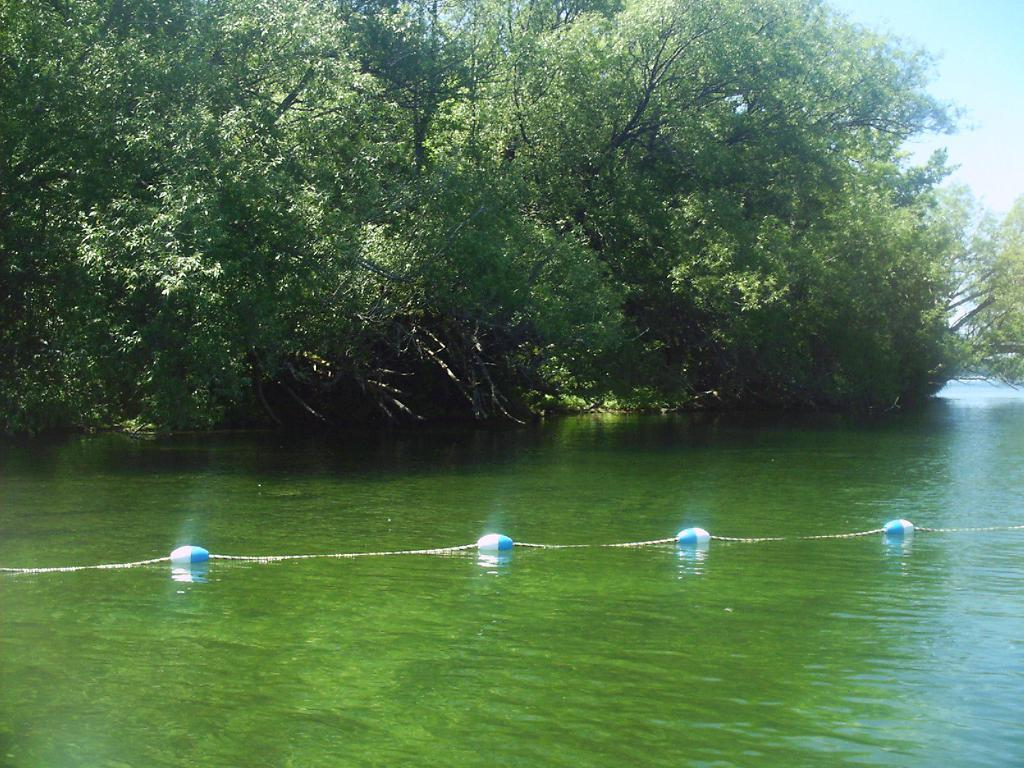What is at the bottom of the image? There is water at the bottom of the image. What can be seen in the middle of the image? There are objects that resemble balloons in the middle of the image. What type of vegetation is visible in the image? There are trees visible in the image. What part of the sky is visible in the image? The sky is visible in the top right-hand side of the image. What word is written on the trees in the image? There are no words written on the trees in the image; only the trees themselves are visible. What type of toys can be seen in the image? There are no toys present in the image. 